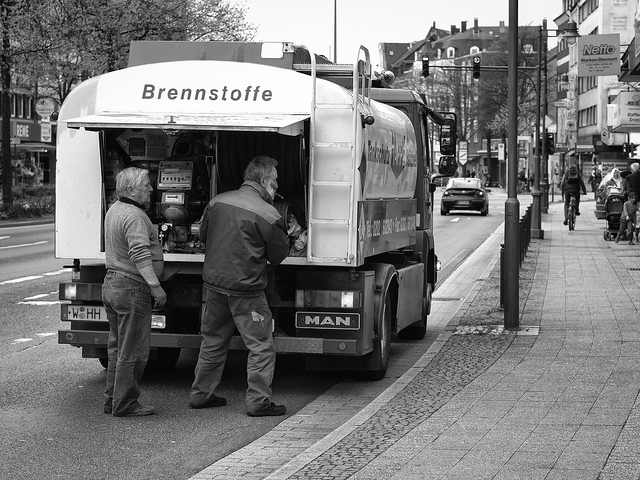Please transcribe the text in this image. Brennstoffe W HH MAN Netto RENE 